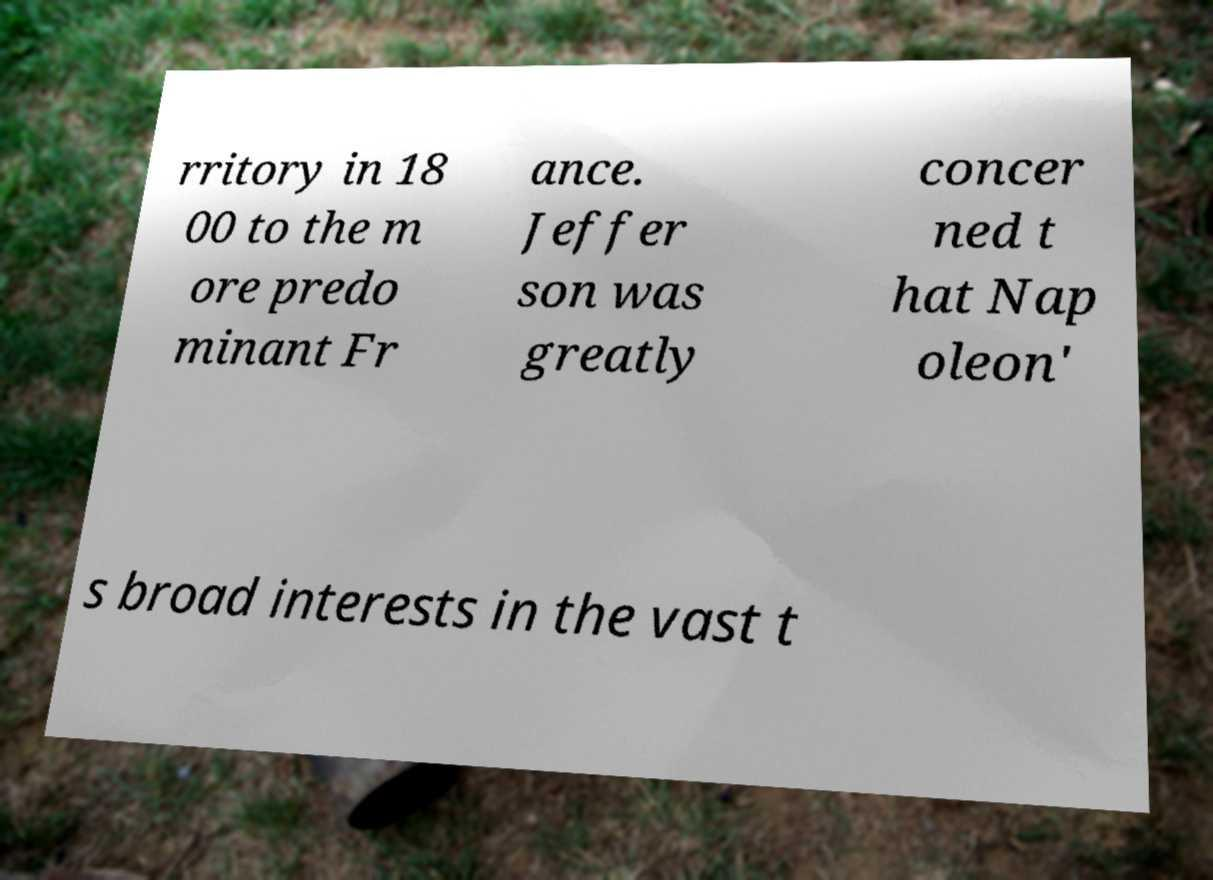Could you extract and type out the text from this image? rritory in 18 00 to the m ore predo minant Fr ance. Jeffer son was greatly concer ned t hat Nap oleon' s broad interests in the vast t 